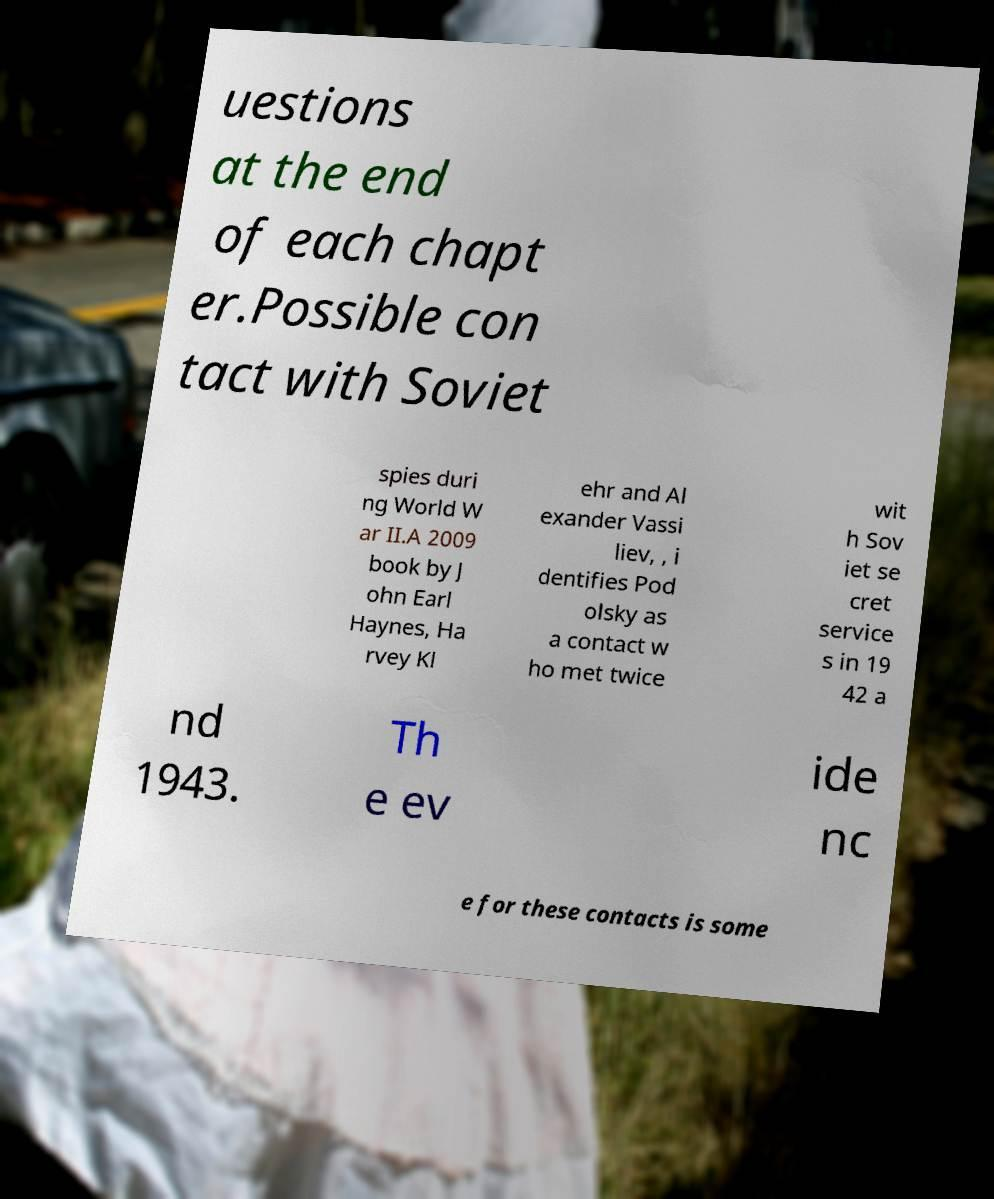Please read and relay the text visible in this image. What does it say? uestions at the end of each chapt er.Possible con tact with Soviet spies duri ng World W ar II.A 2009 book by J ohn Earl Haynes, Ha rvey Kl ehr and Al exander Vassi liev, , i dentifies Pod olsky as a contact w ho met twice wit h Sov iet se cret service s in 19 42 a nd 1943. Th e ev ide nc e for these contacts is some 